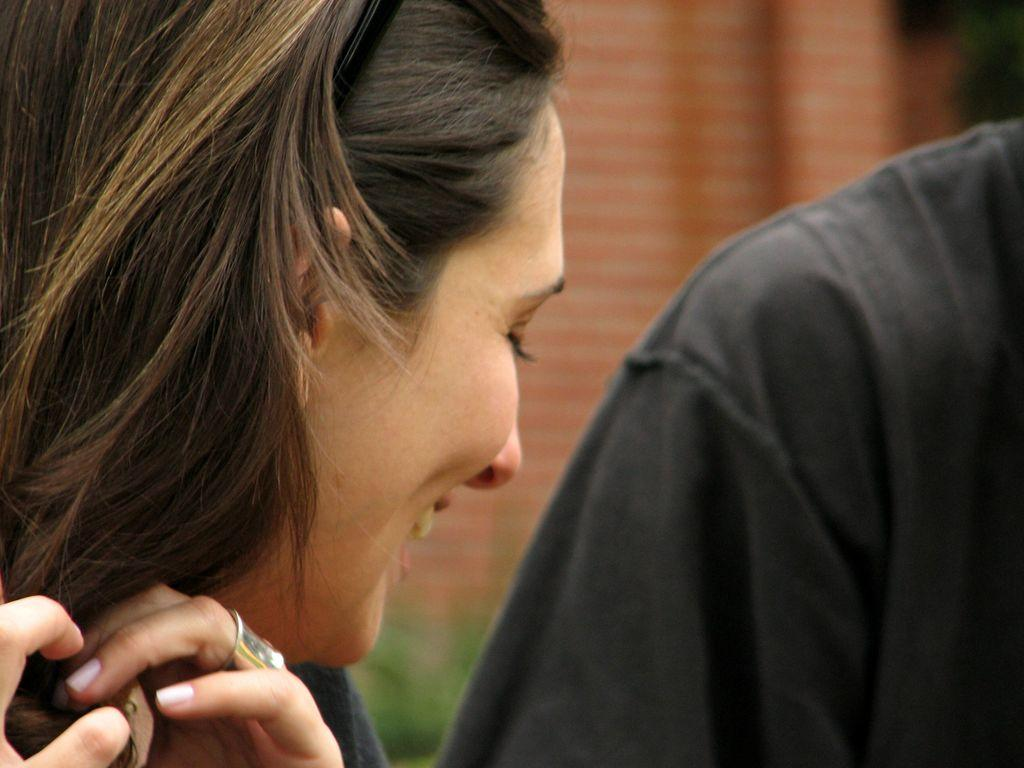How many people are in the image? There are people in the image, but the exact number is not specified. Can you describe the expression of one of the people? One of the people is smiling. What can be seen in the background of the image? There is a wall and a tree visible in the background of the image. What type of frame is around the son in the image? There is no son present in the image, and therefore no frame around him. What kind of mountain can be seen in the background of the image? There is no mountain visible in the background of the image; it features a wall and a tree. 